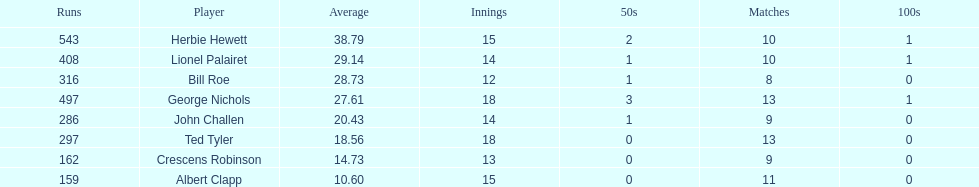What were the number of innings albert clapp had? 15. 